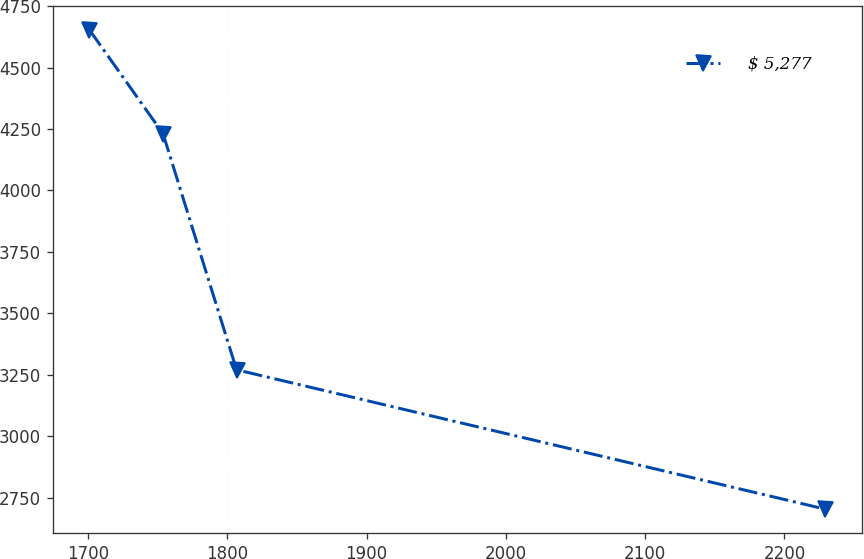<chart> <loc_0><loc_0><loc_500><loc_500><line_chart><ecel><fcel>$ 5,277<nl><fcel>1700.96<fcel>4653.76<nl><fcel>1753.78<fcel>4231.55<nl><fcel>1806.6<fcel>3270.16<nl><fcel>2229.14<fcel>2703.02<nl></chart> 